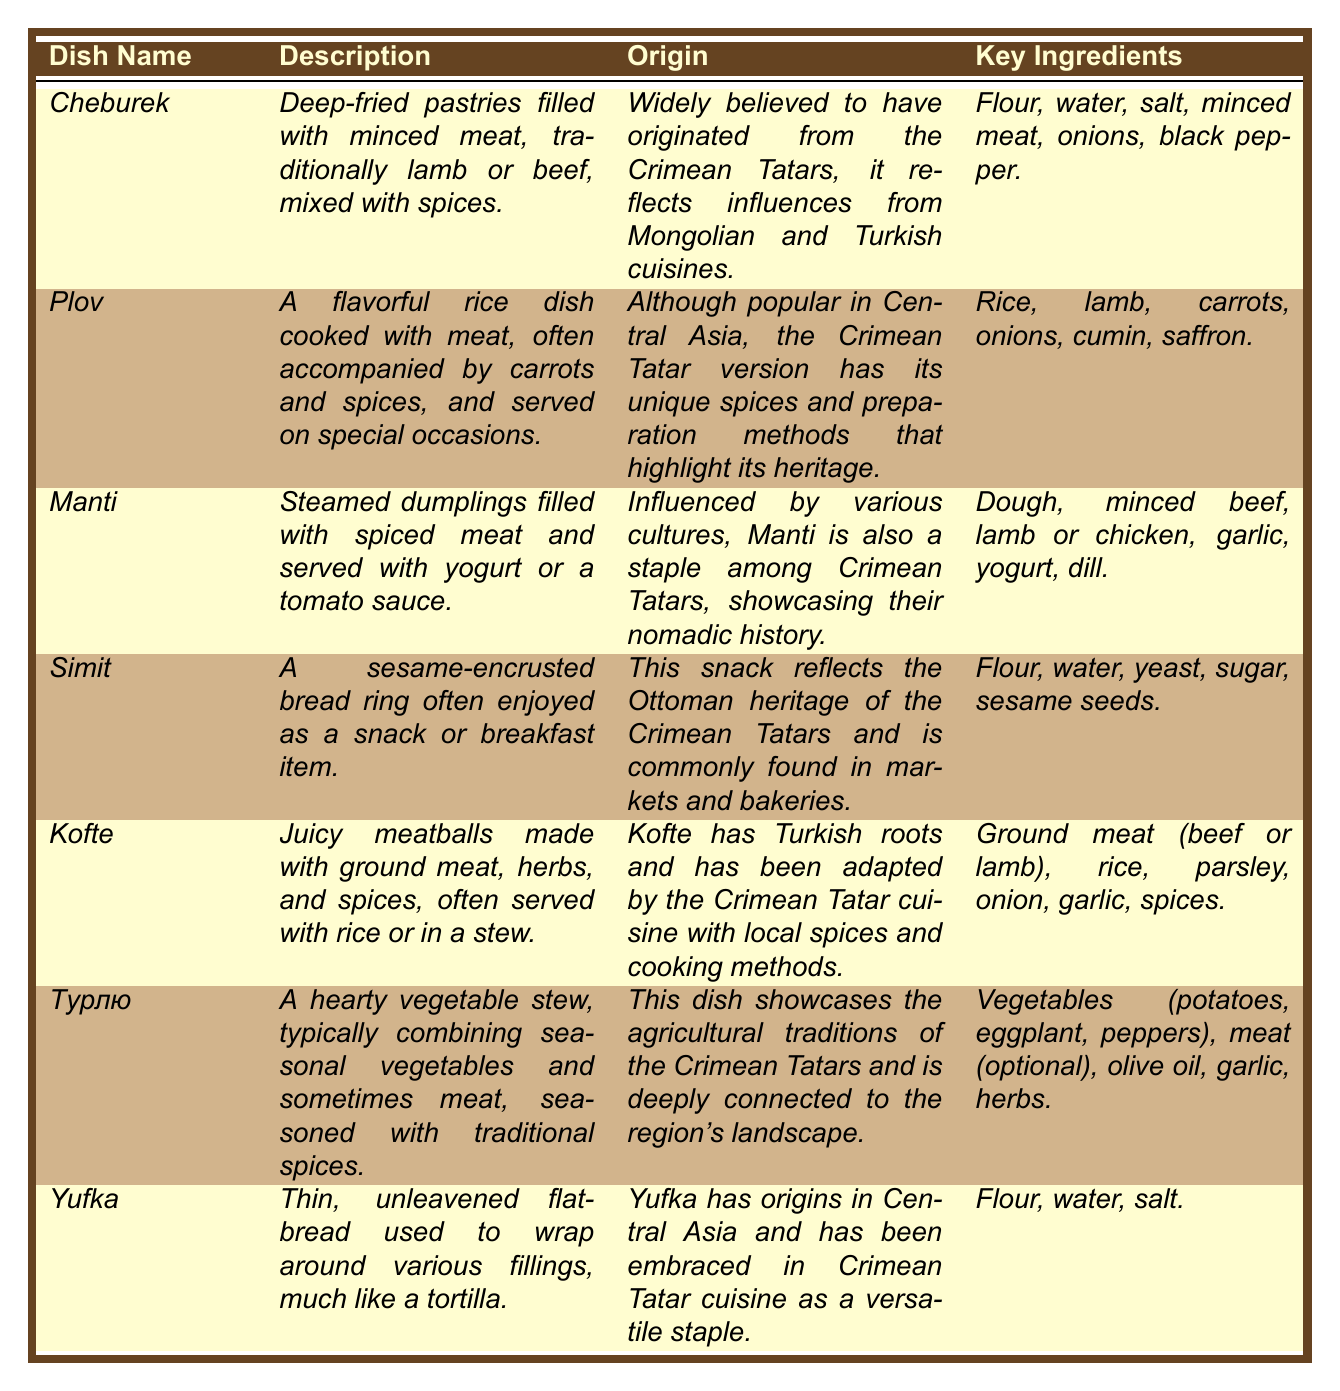What is the key ingredient in *Cheburek*? The table lists the key ingredients for *Cheburek*, which are flour, water, salt, minced meat, onions, and black pepper. The first row provides this information specifically.
Answer: Flour, water, salt, minced meat, onions, black pepper Which dish is described as a flavorful rice dish? By looking at the descriptions, *Plov* is identified as a flavorful rice dish cooked with meat, accompanied by carrots and spices, as seen in the second row.
Answer: *Plov* Is *Yufka* a bread or a type of meat dish? The table provides a description indicating that *Yufka* is a thin unleavened flatbread. This confirms that it is not a meat dish.
Answer: It is a bread How many dishes include lamb as a key ingredient? The dishes *Plov*, *Kofte*, and *Manti* contain lamb based on their key ingredients listed in the table. Adding these gives us a total of three dishes.
Answer: Three dishes Which dish has origins believed to be influenced by Mongolian and Turkish cuisines? The origin of *Cheburek* mentions influences from both Mongolian and Turkish cuisines, making it the dish that fits this criterion.
Answer: *Cheburek* What are the main ingredients in *Tурлю*? The table lists the main ingredients for *Tурлю* as vegetables (potatoes, eggplant, peppers), optional meat, olive oil, garlic, and herbs. This is found in the sixth row.
Answer: Vegetables, optional meat, olive oil, garlic, herbs Which dish is associated with Ottoman heritage? *Simit* is explicitly stated to reflect the Ottoman heritage of the Crimean Tatars, as described in the fourth row of the table.
Answer: *Simit* How is *Manti* prepared? The description of *Manti* states that it is a steamed dish filled with spiced meat and served with yogurt or tomato sauce, indicating the method of preparation.
Answer: Steamed How many dishes are described as having seasonal vegetables? According to the descriptions, only *Tурлю* is specifically mentioned as a hearty vegetable stew that combines seasonal vegetables.
Answer: One dish What similarities do *Kofte* and *Manti* share regarding their preparation? Both *Kofte* and *Manti* involve ground meat as a common key ingredient, hence sharing this preparation aspect, although their final forms differ.
Answer: They both involve ground meat 